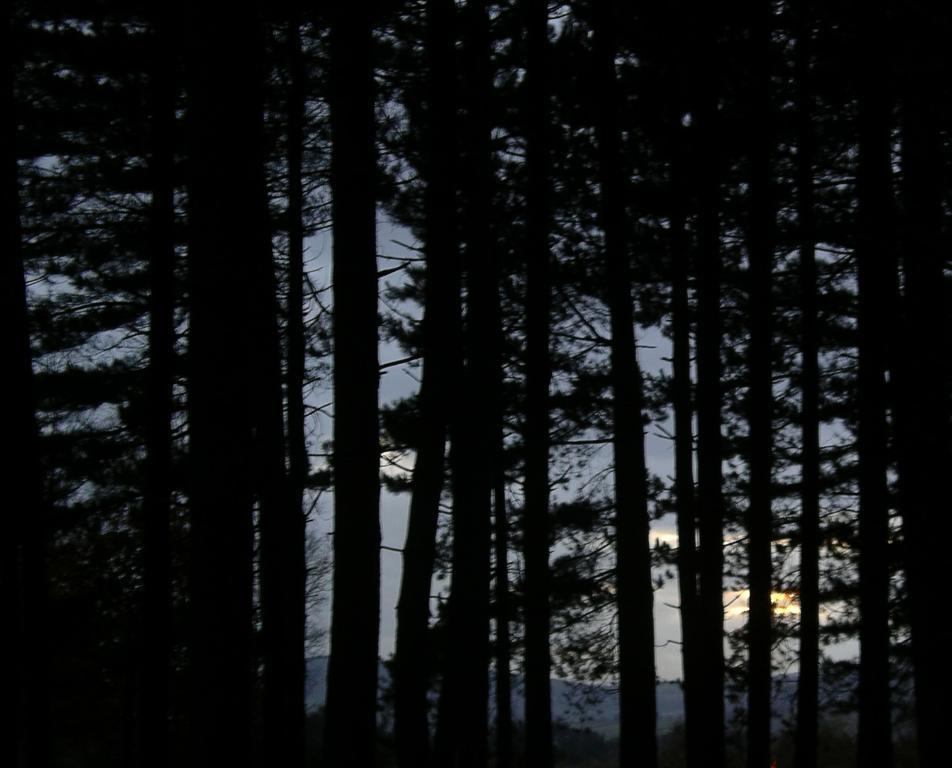What type of vegetation can be seen in the image? There are trees in the image. What is visible behind the trees in the image? The sky is visible behind the trees in the image. What type of shade is provided by the trees in the image? There is no mention of shade or any specific type of shade in the image. 